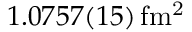Convert formula to latex. <formula><loc_0><loc_0><loc_500><loc_500>1 . 0 7 5 7 ( 1 5 ) \, f m ^ { 2 }</formula> 